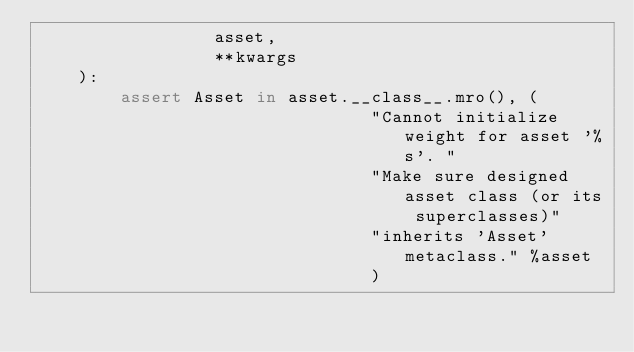<code> <loc_0><loc_0><loc_500><loc_500><_Python_>                 asset,
                 **kwargs
    ):
        assert Asset in asset.__class__.mro(), (
                                "Cannot initialize weight for asset '%s'. " 
                                "Make sure designed asset class (or its superclasses)"
                                "inherits 'Asset' metaclass." %asset
                                )
        </code> 